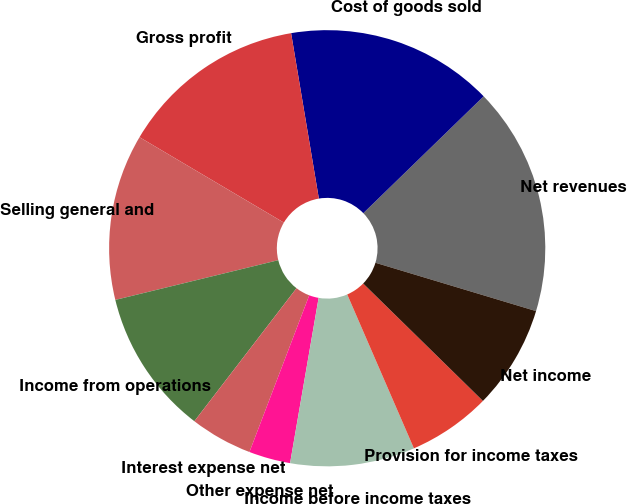<chart> <loc_0><loc_0><loc_500><loc_500><pie_chart><fcel>Net revenues<fcel>Cost of goods sold<fcel>Gross profit<fcel>Selling general and<fcel>Income from operations<fcel>Interest expense net<fcel>Other expense net<fcel>Income before income taxes<fcel>Provision for income taxes<fcel>Net income<nl><fcel>16.92%<fcel>15.38%<fcel>13.85%<fcel>12.31%<fcel>10.77%<fcel>4.62%<fcel>3.08%<fcel>9.23%<fcel>6.15%<fcel>7.69%<nl></chart> 